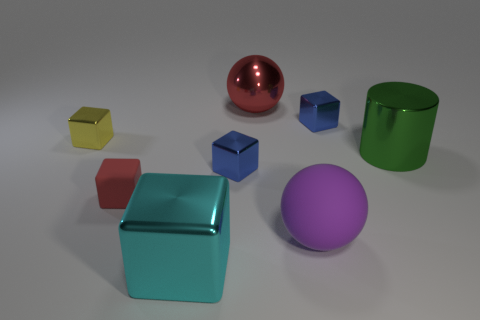Is the size of the cylinder the same as the blue shiny object that is behind the small yellow thing?
Offer a very short reply. No. What number of other things are there of the same material as the green thing
Offer a terse response. 5. Are there any other things that have the same shape as the purple thing?
Your response must be concise. Yes. There is a tiny shiny cube on the left side of the tiny rubber thing left of the tiny thing that is right of the red metal ball; what is its color?
Ensure brevity in your answer.  Yellow. What is the shape of the metallic object that is both behind the tiny yellow thing and to the right of the big purple ball?
Give a very brief answer. Cube. Are there any other things that are the same size as the purple thing?
Make the answer very short. Yes. The sphere that is in front of the large thing to the right of the big purple matte sphere is what color?
Your response must be concise. Purple. The matte thing that is on the right side of the blue metal thing that is to the left of the blue metallic object behind the green metal object is what shape?
Give a very brief answer. Sphere. There is a block that is to the right of the small yellow metallic cube and left of the cyan metal cube; how big is it?
Ensure brevity in your answer.  Small. How many small cubes have the same color as the large cylinder?
Your answer should be compact. 0. 